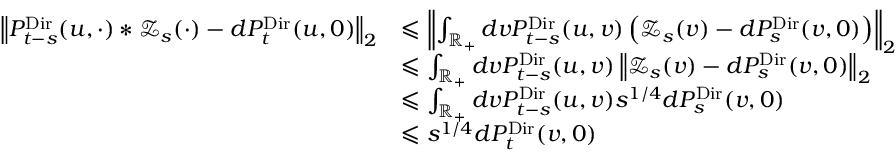<formula> <loc_0><loc_0><loc_500><loc_500>\begin{array} { r l } { \left \| P _ { t - s } ^ { D i r } ( u , \cdot ) \ast \mathcal { Z } _ { s } ( \cdot ) - d P _ { t } ^ { D i r } ( u , 0 ) \right \| _ { 2 } } & { \leqslant \left \| \int _ { \mathbb { R } _ { + } } d v P _ { t - s } ^ { D i r } ( u , v ) \left ( \mathcal { Z } _ { s } ( v ) - d P _ { s } ^ { D i r } ( v , 0 ) \right ) \right \| _ { 2 } } \\ & { \leqslant \int _ { \mathbb { R } _ { + } } d v P _ { t - s } ^ { D i r } ( u , v ) \left \| \mathcal { Z } _ { s } ( v ) - d P _ { s } ^ { D i r } ( v , 0 ) \right \| _ { 2 } } \\ & { \leqslant \int _ { \mathbb { R } _ { + } } d v P _ { t - s } ^ { D i r } ( u , v ) s ^ { 1 / 4 } d P _ { s } ^ { D i r } ( v , 0 ) } \\ & { \leqslant s ^ { 1 / 4 } d P _ { t } ^ { D i r } ( v , 0 ) } \end{array}</formula> 